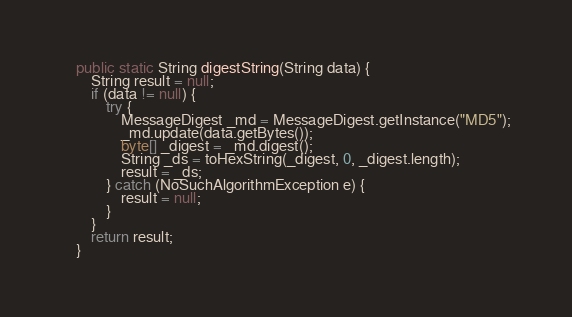Convert code to text. <code><loc_0><loc_0><loc_500><loc_500><_Java_>    public static String digestString(String data) {
        String result = null;
        if (data != null) {
            try {
                MessageDigest _md = MessageDigest.getInstance("MD5");
                _md.update(data.getBytes());
                byte[] _digest = _md.digest();
                String _ds = toHexString(_digest, 0, _digest.length);
                result = _ds;
            } catch (NoSuchAlgorithmException e) {
                result = null;
            }
        }
        return result;
    }
</code> 